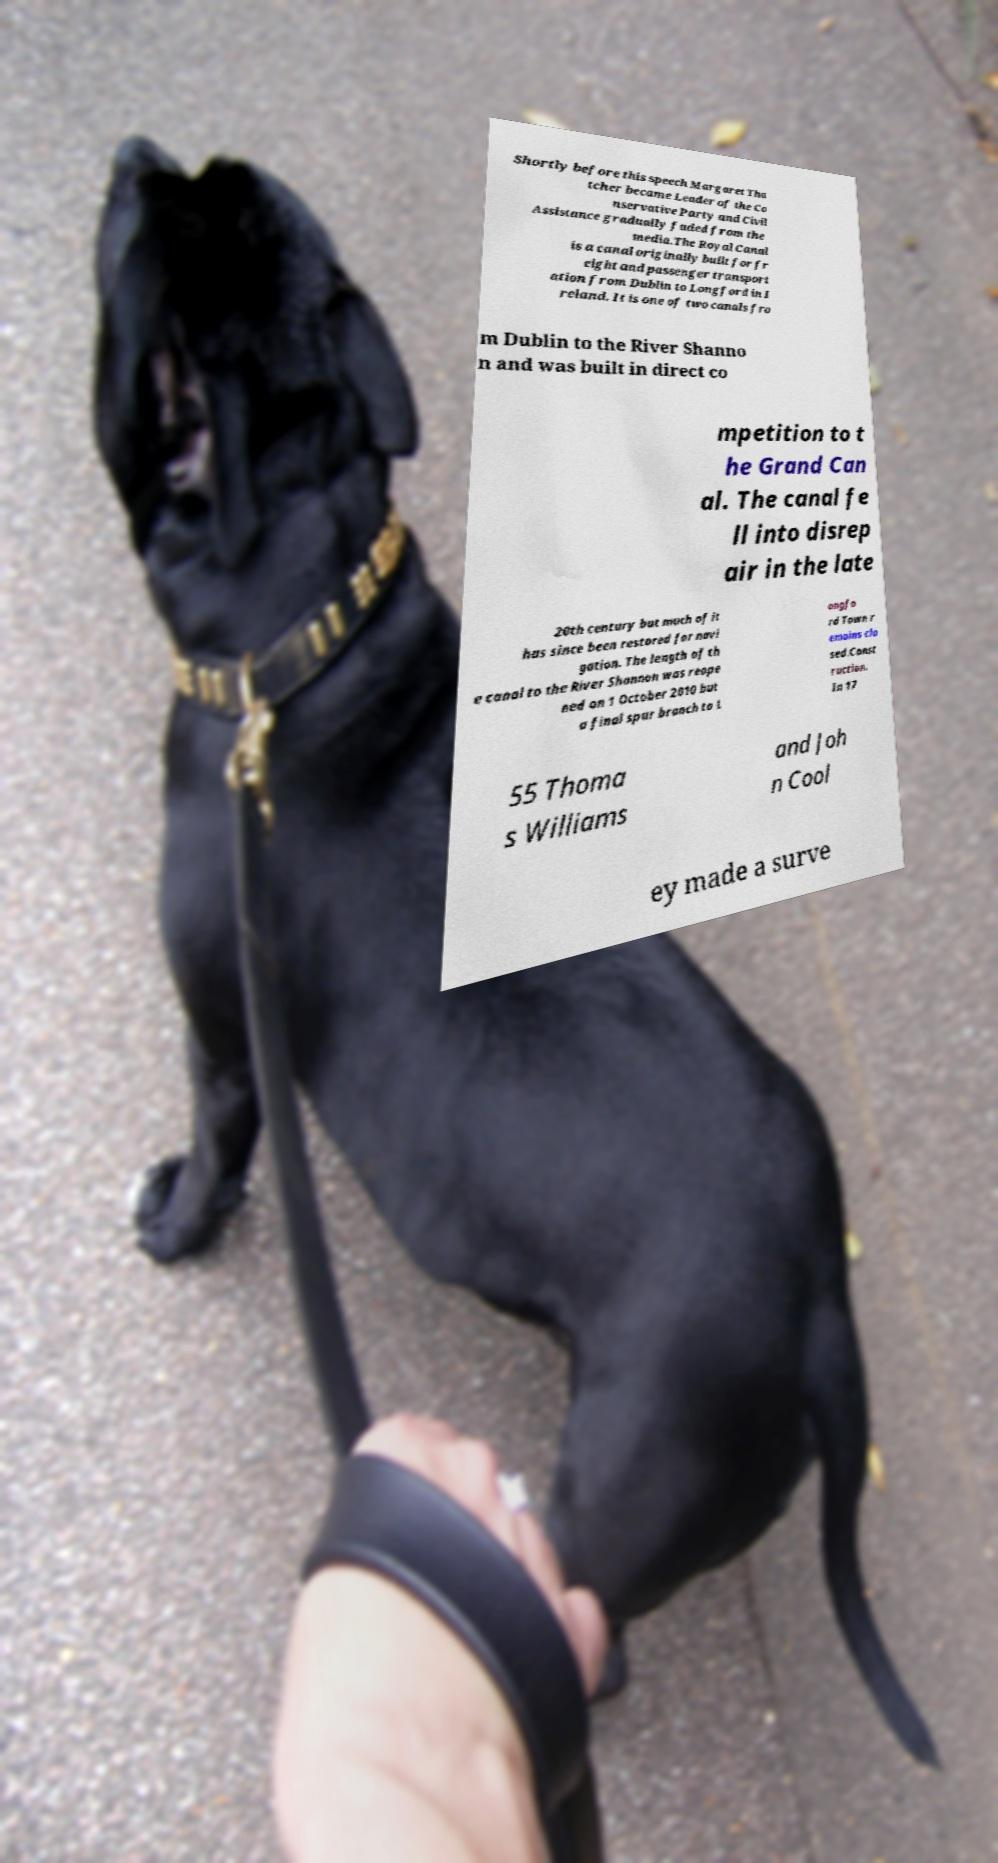I need the written content from this picture converted into text. Can you do that? Shortly before this speech Margaret Tha tcher became Leader of the Co nservative Party and Civil Assistance gradually faded from the media.The Royal Canal is a canal originally built for fr eight and passenger transport ation from Dublin to Longford in I reland. It is one of two canals fro m Dublin to the River Shanno n and was built in direct co mpetition to t he Grand Can al. The canal fe ll into disrep air in the late 20th century but much of it has since been restored for navi gation. The length of th e canal to the River Shannon was reope ned on 1 October 2010 but a final spur branch to L ongfo rd Town r emains clo sed.Const ruction. In 17 55 Thoma s Williams and Joh n Cool ey made a surve 